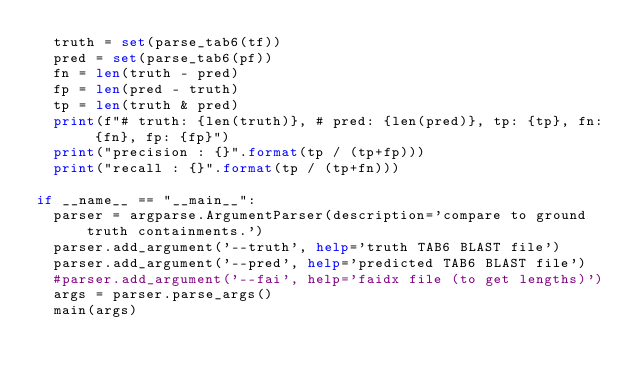<code> <loc_0><loc_0><loc_500><loc_500><_Python_>	truth = set(parse_tab6(tf))
	pred = set(parse_tab6(pf))
	fn = len(truth - pred)
	fp = len(pred - truth)
	tp = len(truth & pred)
	print(f"# truth: {len(truth)}, # pred: {len(pred)}, tp: {tp}, fn: {fn}, fp: {fp}")
	print("precision : {}".format(tp / (tp+fp)))
	print("recall : {}".format(tp / (tp+fn)))

if __name__ == "__main__":
	parser = argparse.ArgumentParser(description='compare to ground truth containments.')
	parser.add_argument('--truth', help='truth TAB6 BLAST file')
	parser.add_argument('--pred', help='predicted TAB6 BLAST file')
	#parser.add_argument('--fai', help='faidx file (to get lengths)')
	args = parser.parse_args()
	main(args)
</code> 